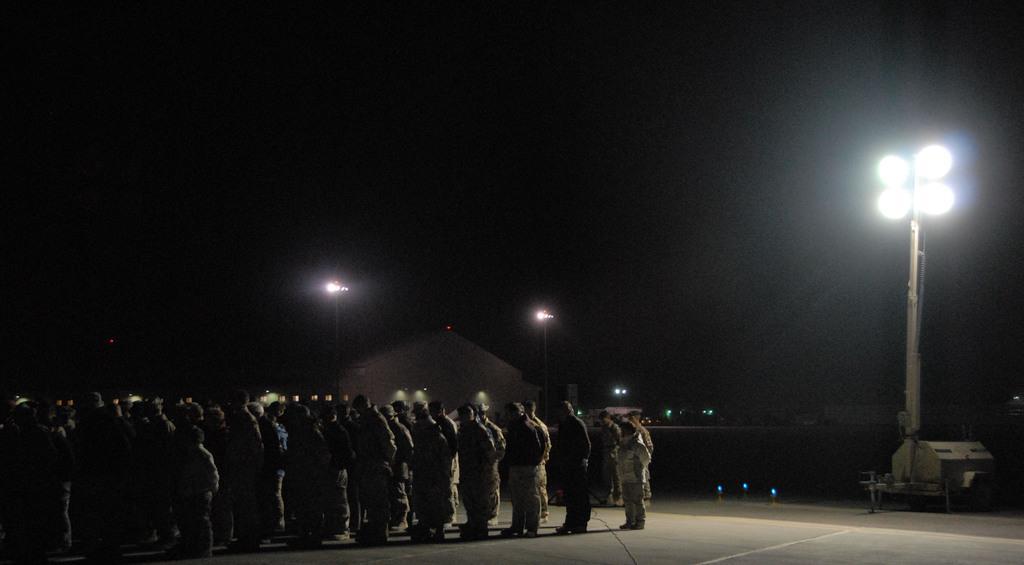In one or two sentences, can you explain what this image depicts? In this image I can see the group of people with dresses. To the right I can see many light poles and the house. And there is a black background. 